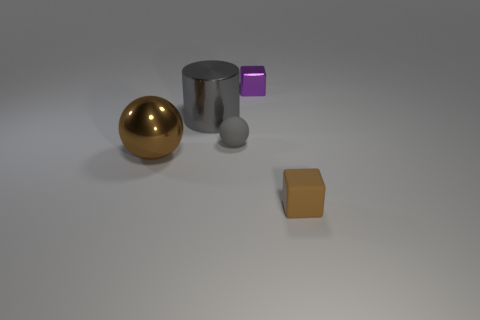Can you infer anything about the size of the objects relative to each other? Relative sizes can be inferred by the comparative shadows and perspective. The large gold sphere seems to be the most prominent, followed by the silver cylinder. The purple-blue cube and the orange square are smaller in scale. The grey sphere has the least visual impact, suggesting it's the smallest object regarding the others' sizes or it's further in the background than it appears. 